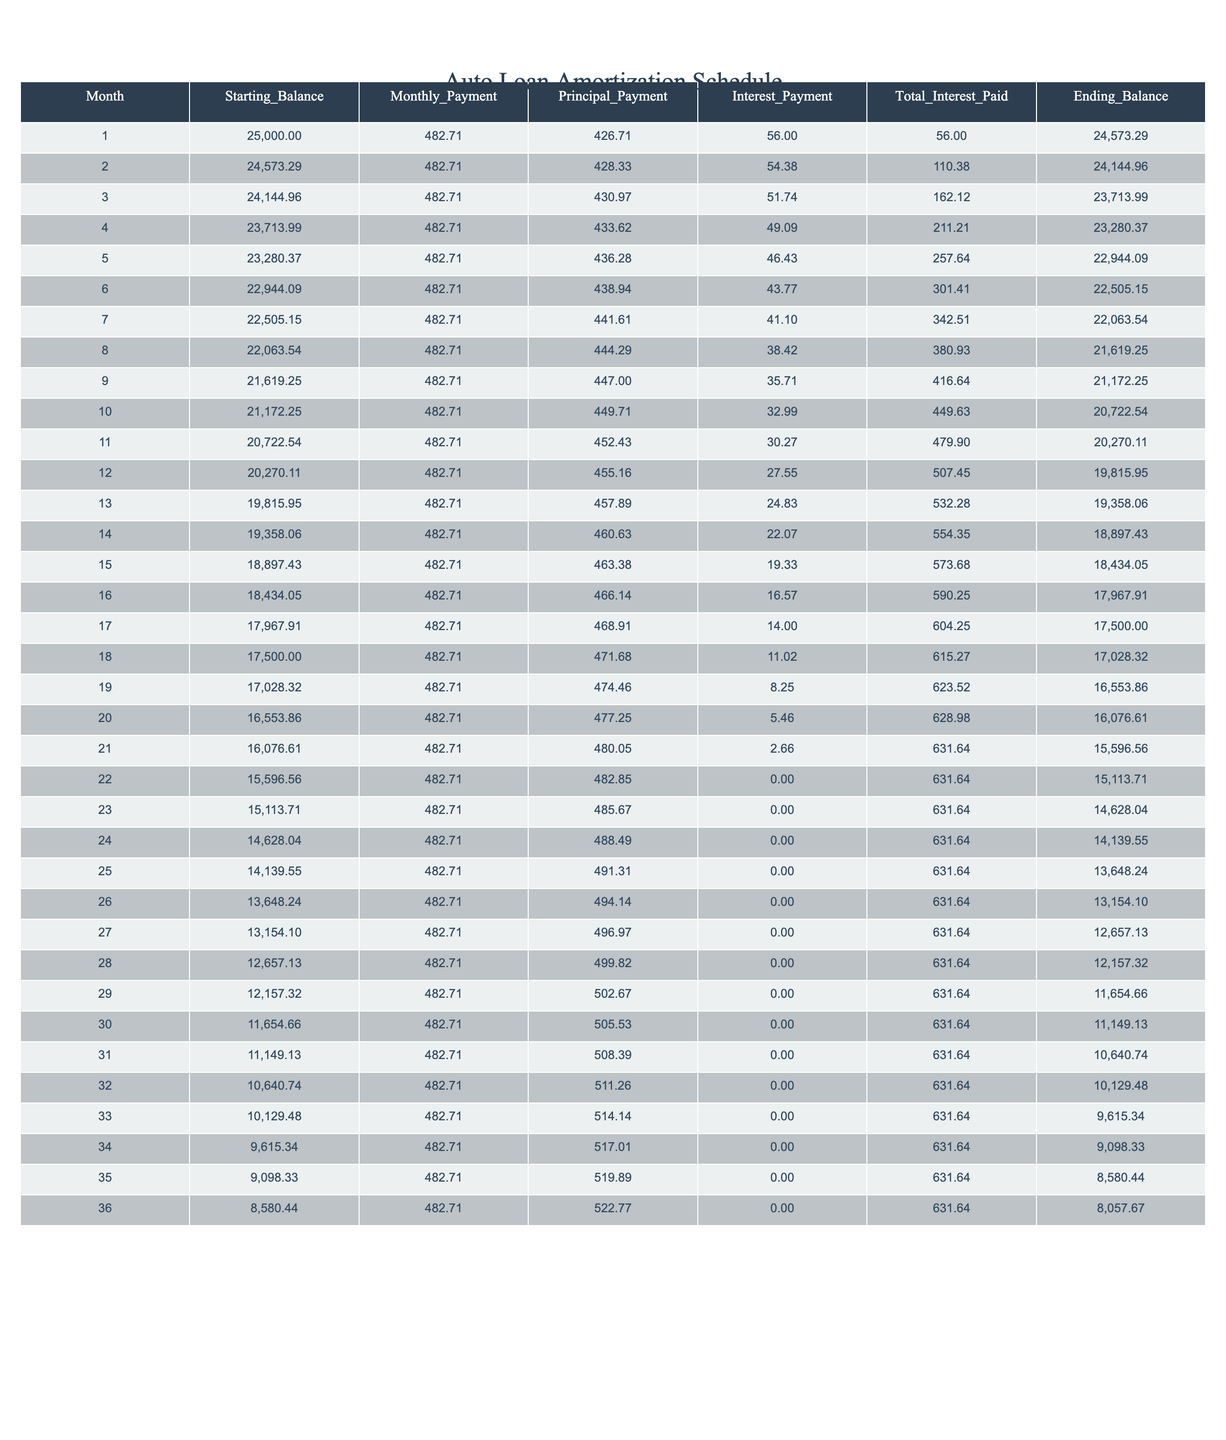What is the total interest paid by the end of month 12? The table indicates that the total interest paid by month 12 is listed under the "Total_Interest_Paid" column for month 12, which shows a value of 507.45.
Answer: 507.45 How much is the principal payment made in month 5? In the table, the principal payment made in month 5 is found under the "Principal_Payment" column for month 5, which shows a value of 436.28.
Answer: 436.28 What is the difference between the starting balance and ending balance in month 1? For month 1, the starting balance is 25000 and the ending balance is 24573.29. The difference is calculated as 25000 - 24573.29 = 426.71, which represents the principal payment for that month.
Answer: 426.71 What is the average monthly payment over the 36 months? The monthly payment is constant at 482.71 across all months. Therefore, the average monthly payment is the same value, which is 482.71.
Answer: 482.71 Did the principal payment increase every month? Reviewing the "Principal_Payment" column for several months, it shows an increasing trend throughout the loan period, confirming that principal payments do indeed increase each month. Thus, the answer is "Yes."
Answer: Yes What is the total principal paid by the end of month 36? By summing the principal payments from all 36 months using the values from the "Principal_Payment" column, we find the total principal paid is 522.77 at month 36, which confirms an ongoing repayment structure where the total accumulates over time.
Answer: 522.77 How much total interest was paid by the end of the loan term (month 36)? From the "Total_Interest_Paid" column for month 36, it shows a total of 631.64. This indicates how much interest accumulates over the duration of the loan, providing insight into the overall cost associated with the financing.
Answer: 631.64 What month shows the highest interest payment? Examining the "Interest_Payment" column, the highest value occurs in month 1 with an amount of 56.00; hence, it's noted as the highest payment for interest during the initial phase of the loan.
Answer: Month 1 How much does the ending balance decrease from month 6 to month 12? The ending balance for month 6 is 22505.15 and for month 12 is 19815.95. The decrease is calculated as 22505.15 - 19815.95 = 2689.20, showing the reduction in remaining balance as payments are made.
Answer: 2689.20 What is the principal payment in month 22? In the table, the principal payment for month 22 is 482.85 listed under the "Principal_Payment" column, indicating how much of the payment was allocated to reducing the loan balance at that point.
Answer: 482.85 